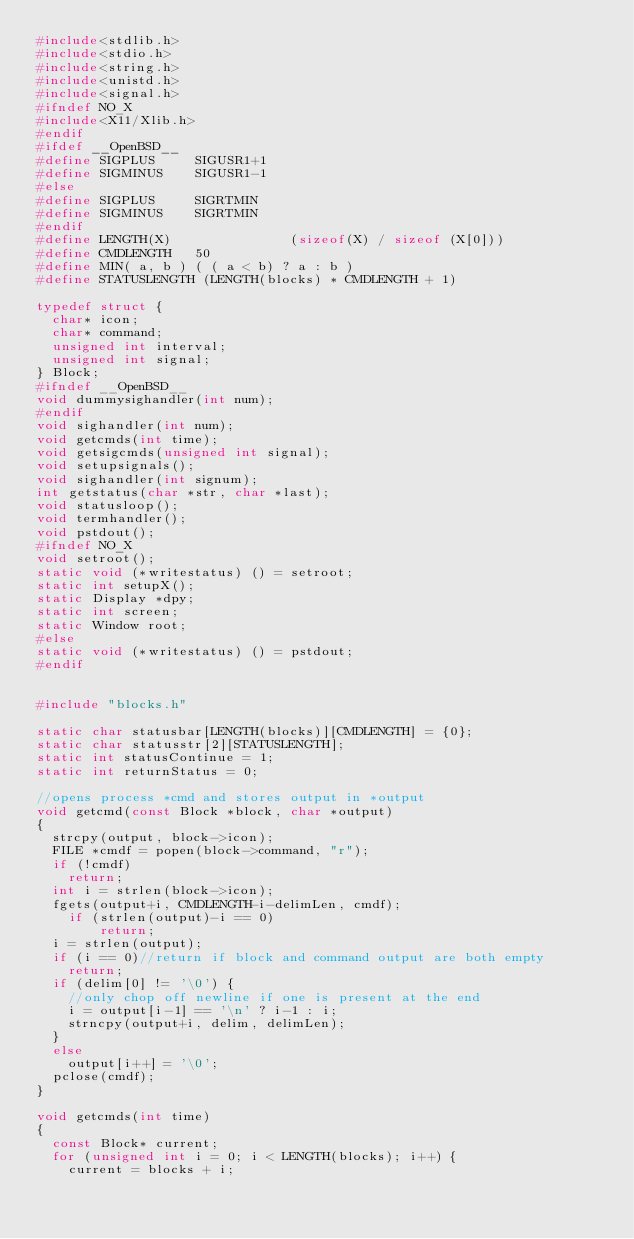<code> <loc_0><loc_0><loc_500><loc_500><_C_>#include<stdlib.h>
#include<stdio.h>
#include<string.h>
#include<unistd.h>
#include<signal.h>
#ifndef NO_X
#include<X11/Xlib.h>
#endif
#ifdef __OpenBSD__
#define SIGPLUS			SIGUSR1+1
#define SIGMINUS		SIGUSR1-1
#else
#define SIGPLUS			SIGRTMIN
#define SIGMINUS		SIGRTMIN
#endif
#define LENGTH(X)               (sizeof(X) / sizeof (X[0]))
#define CMDLENGTH		50
#define MIN( a, b ) ( ( a < b) ? a : b )
#define STATUSLENGTH (LENGTH(blocks) * CMDLENGTH + 1)

typedef struct {
	char* icon;
	char* command;
	unsigned int interval;
	unsigned int signal;
} Block;
#ifndef __OpenBSD__
void dummysighandler(int num);
#endif
void sighandler(int num);
void getcmds(int time);
void getsigcmds(unsigned int signal);
void setupsignals();
void sighandler(int signum);
int getstatus(char *str, char *last);
void statusloop();
void termhandler();
void pstdout();
#ifndef NO_X
void setroot();
static void (*writestatus) () = setroot;
static int setupX();
static Display *dpy;
static int screen;
static Window root;
#else
static void (*writestatus) () = pstdout;
#endif


#include "blocks.h"

static char statusbar[LENGTH(blocks)][CMDLENGTH] = {0};
static char statusstr[2][STATUSLENGTH];
static int statusContinue = 1;
static int returnStatus = 0;

//opens process *cmd and stores output in *output
void getcmd(const Block *block, char *output)
{
	strcpy(output, block->icon);
	FILE *cmdf = popen(block->command, "r");
	if (!cmdf)
		return;
	int i = strlen(block->icon);
	fgets(output+i, CMDLENGTH-i-delimLen, cmdf);
    if (strlen(output)-i == 0)
        return;
	i = strlen(output);
	if (i == 0)//return if block and command output are both empty
		return;
	if (delim[0] != '\0') {
		//only chop off newline if one is present at the end
		i = output[i-1] == '\n' ? i-1 : i;
		strncpy(output+i, delim, delimLen);
	}
	else
		output[i++] = '\0';
	pclose(cmdf);
}

void getcmds(int time)
{
	const Block* current;
	for (unsigned int i = 0; i < LENGTH(blocks); i++) {
		current = blocks + i;</code> 